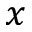Convert formula to latex. <formula><loc_0><loc_0><loc_500><loc_500>x</formula> 